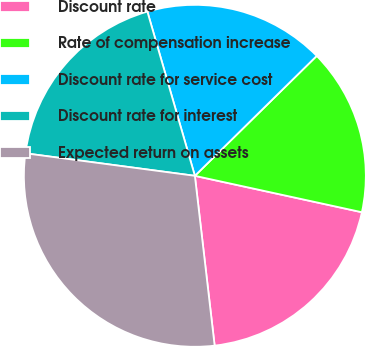Convert chart. <chart><loc_0><loc_0><loc_500><loc_500><pie_chart><fcel>Discount rate<fcel>Rate of compensation increase<fcel>Discount rate for service cost<fcel>Discount rate for interest<fcel>Expected return on assets<nl><fcel>19.74%<fcel>15.79%<fcel>17.11%<fcel>18.42%<fcel>28.95%<nl></chart> 